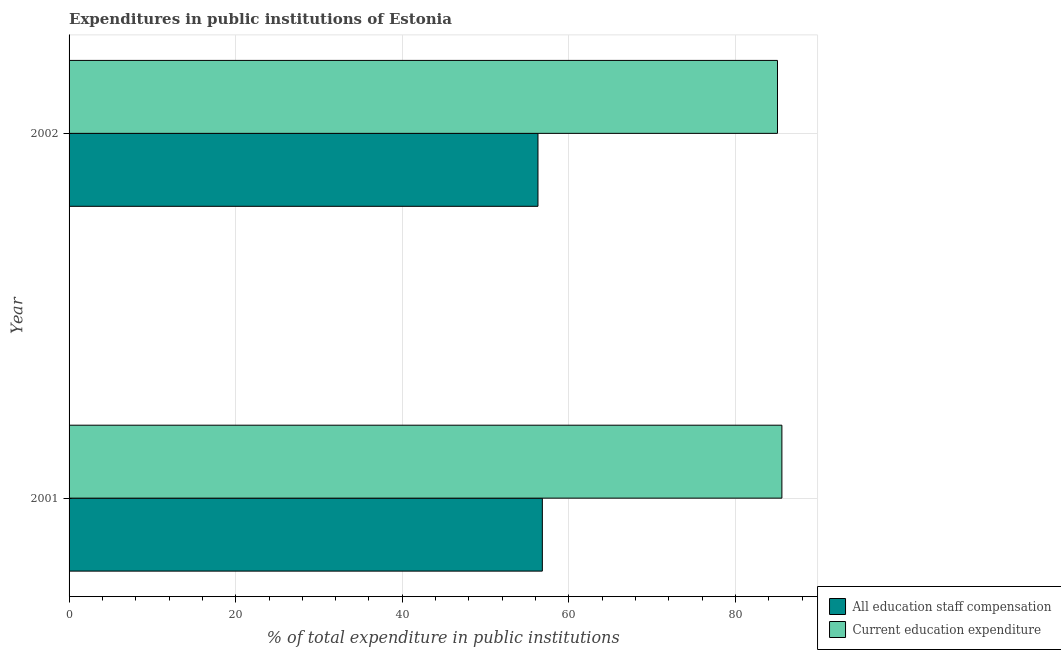Are the number of bars per tick equal to the number of legend labels?
Ensure brevity in your answer.  Yes. How many bars are there on the 1st tick from the top?
Your answer should be compact. 2. How many bars are there on the 1st tick from the bottom?
Provide a succinct answer. 2. What is the expenditure in education in 2001?
Your response must be concise. 85.57. Across all years, what is the maximum expenditure in education?
Provide a short and direct response. 85.57. Across all years, what is the minimum expenditure in education?
Your response must be concise. 85.04. In which year was the expenditure in education minimum?
Offer a very short reply. 2002. What is the total expenditure in education in the graph?
Make the answer very short. 170.61. What is the difference between the expenditure in staff compensation in 2001 and that in 2002?
Offer a very short reply. 0.53. What is the difference between the expenditure in education in 2002 and the expenditure in staff compensation in 2001?
Offer a very short reply. 28.23. What is the average expenditure in staff compensation per year?
Give a very brief answer. 56.55. In the year 2002, what is the difference between the expenditure in education and expenditure in staff compensation?
Your answer should be very brief. 28.75. What is the ratio of the expenditure in staff compensation in 2001 to that in 2002?
Provide a succinct answer. 1.01. What does the 2nd bar from the top in 2002 represents?
Give a very brief answer. All education staff compensation. What does the 1st bar from the bottom in 2002 represents?
Offer a very short reply. All education staff compensation. How many bars are there?
Your response must be concise. 4. Are all the bars in the graph horizontal?
Keep it short and to the point. Yes. How many years are there in the graph?
Offer a terse response. 2. What is the difference between two consecutive major ticks on the X-axis?
Offer a very short reply. 20. Does the graph contain any zero values?
Provide a succinct answer. No. Does the graph contain grids?
Provide a succinct answer. Yes. Where does the legend appear in the graph?
Offer a very short reply. Bottom right. What is the title of the graph?
Offer a terse response. Expenditures in public institutions of Estonia. What is the label or title of the X-axis?
Your answer should be compact. % of total expenditure in public institutions. What is the label or title of the Y-axis?
Make the answer very short. Year. What is the % of total expenditure in public institutions of All education staff compensation in 2001?
Give a very brief answer. 56.81. What is the % of total expenditure in public institutions in Current education expenditure in 2001?
Give a very brief answer. 85.57. What is the % of total expenditure in public institutions of All education staff compensation in 2002?
Give a very brief answer. 56.29. What is the % of total expenditure in public institutions in Current education expenditure in 2002?
Make the answer very short. 85.04. Across all years, what is the maximum % of total expenditure in public institutions in All education staff compensation?
Ensure brevity in your answer.  56.81. Across all years, what is the maximum % of total expenditure in public institutions of Current education expenditure?
Your answer should be compact. 85.57. Across all years, what is the minimum % of total expenditure in public institutions of All education staff compensation?
Make the answer very short. 56.29. Across all years, what is the minimum % of total expenditure in public institutions of Current education expenditure?
Ensure brevity in your answer.  85.04. What is the total % of total expenditure in public institutions in All education staff compensation in the graph?
Provide a succinct answer. 113.1. What is the total % of total expenditure in public institutions in Current education expenditure in the graph?
Your response must be concise. 170.61. What is the difference between the % of total expenditure in public institutions in All education staff compensation in 2001 and that in 2002?
Your response must be concise. 0.53. What is the difference between the % of total expenditure in public institutions in Current education expenditure in 2001 and that in 2002?
Ensure brevity in your answer.  0.53. What is the difference between the % of total expenditure in public institutions in All education staff compensation in 2001 and the % of total expenditure in public institutions in Current education expenditure in 2002?
Your answer should be very brief. -28.23. What is the average % of total expenditure in public institutions in All education staff compensation per year?
Provide a short and direct response. 56.55. What is the average % of total expenditure in public institutions of Current education expenditure per year?
Provide a succinct answer. 85.31. In the year 2001, what is the difference between the % of total expenditure in public institutions of All education staff compensation and % of total expenditure in public institutions of Current education expenditure?
Keep it short and to the point. -28.76. In the year 2002, what is the difference between the % of total expenditure in public institutions in All education staff compensation and % of total expenditure in public institutions in Current education expenditure?
Offer a very short reply. -28.75. What is the ratio of the % of total expenditure in public institutions of All education staff compensation in 2001 to that in 2002?
Make the answer very short. 1.01. What is the difference between the highest and the second highest % of total expenditure in public institutions of All education staff compensation?
Keep it short and to the point. 0.53. What is the difference between the highest and the second highest % of total expenditure in public institutions in Current education expenditure?
Offer a terse response. 0.53. What is the difference between the highest and the lowest % of total expenditure in public institutions of All education staff compensation?
Offer a terse response. 0.53. What is the difference between the highest and the lowest % of total expenditure in public institutions in Current education expenditure?
Ensure brevity in your answer.  0.53. 